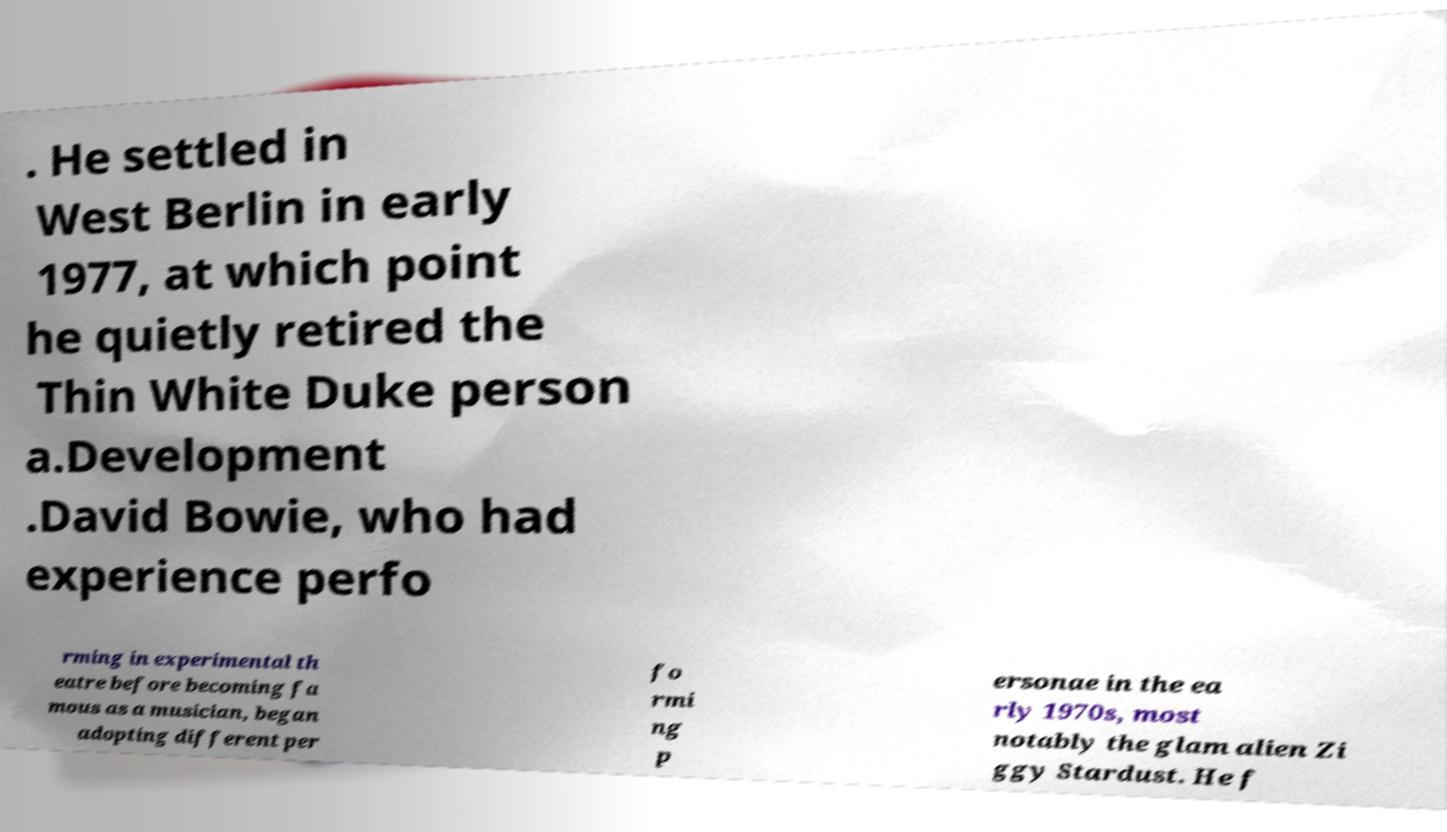What messages or text are displayed in this image? I need them in a readable, typed format. . He settled in West Berlin in early 1977, at which point he quietly retired the Thin White Duke person a.Development .David Bowie, who had experience perfo rming in experimental th eatre before becoming fa mous as a musician, began adopting different per fo rmi ng p ersonae in the ea rly 1970s, most notably the glam alien Zi ggy Stardust. He f 